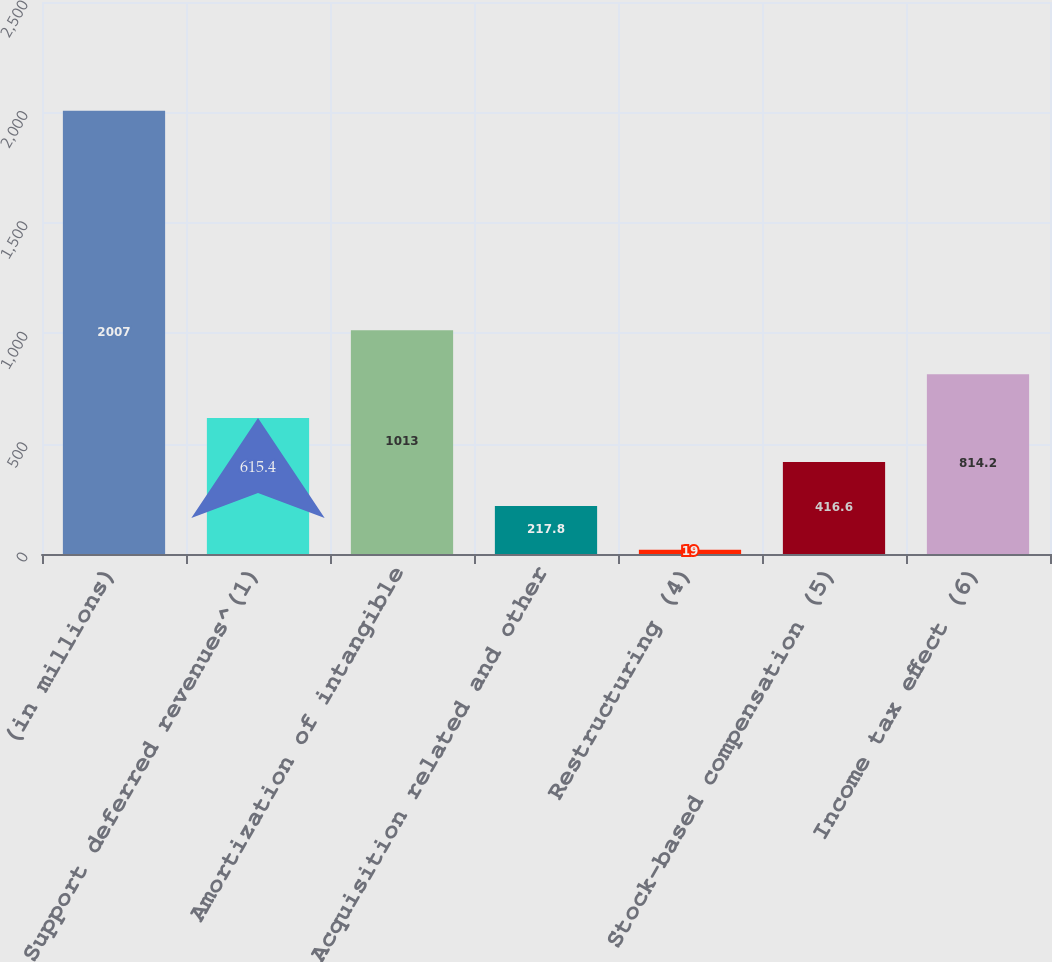Convert chart. <chart><loc_0><loc_0><loc_500><loc_500><bar_chart><fcel>(in millions)<fcel>Support deferred revenues^(1)<fcel>Amortization of intangible<fcel>Acquisition related and other<fcel>Restructuring (4)<fcel>Stock-based compensation (5)<fcel>Income tax effect (6)<nl><fcel>2007<fcel>615.4<fcel>1013<fcel>217.8<fcel>19<fcel>416.6<fcel>814.2<nl></chart> 